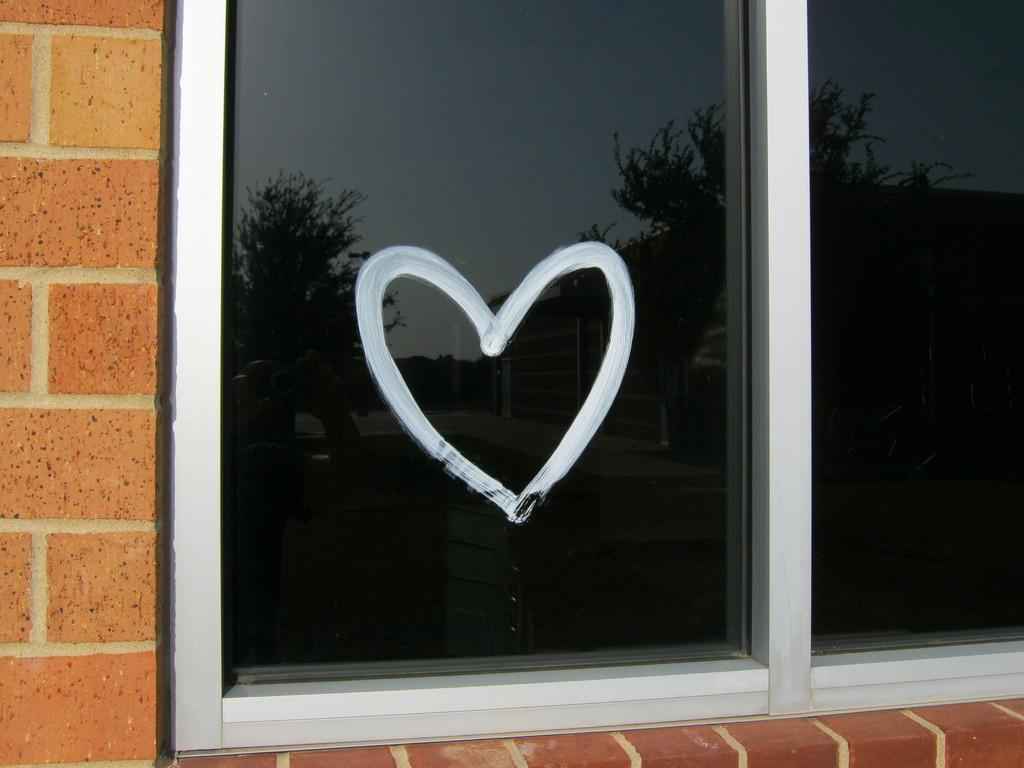What is present on the wall in the image? There is a glass window on the wall in the image. What feature is present on the glass window? There is a heart symbol on the glass window. What is the distance between the bun and the wire in the image? There is no bun or wire present in the image. 